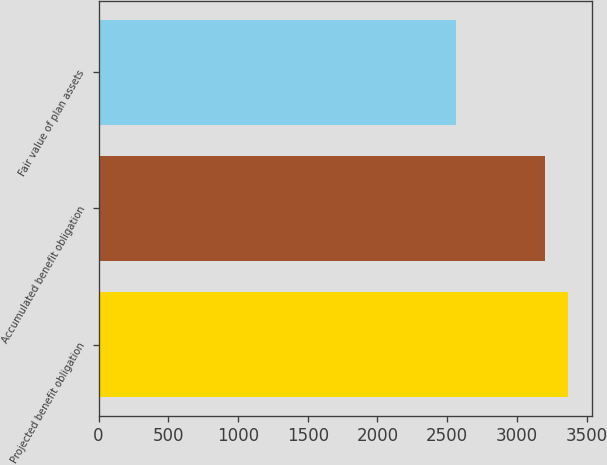Convert chart. <chart><loc_0><loc_0><loc_500><loc_500><bar_chart><fcel>Projected benefit obligation<fcel>Accumulated benefit obligation<fcel>Fair value of plan assets<nl><fcel>3367<fcel>3204<fcel>2563<nl></chart> 